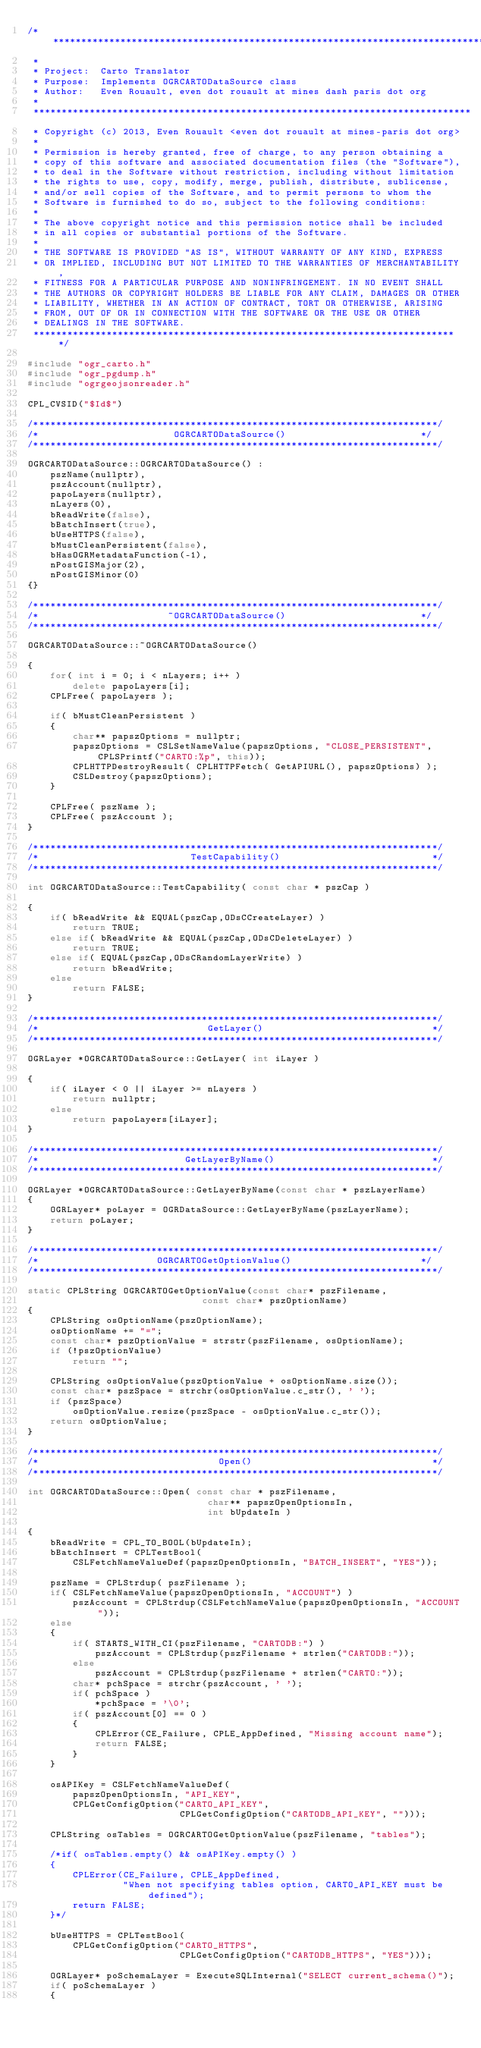<code> <loc_0><loc_0><loc_500><loc_500><_C++_>/******************************************************************************
 *
 * Project:  Carto Translator
 * Purpose:  Implements OGRCARTODataSource class
 * Author:   Even Rouault, even dot rouault at mines dash paris dot org
 *
 ******************************************************************************
 * Copyright (c) 2013, Even Rouault <even dot rouault at mines-paris dot org>
 *
 * Permission is hereby granted, free of charge, to any person obtaining a
 * copy of this software and associated documentation files (the "Software"),
 * to deal in the Software without restriction, including without limitation
 * the rights to use, copy, modify, merge, publish, distribute, sublicense,
 * and/or sell copies of the Software, and to permit persons to whom the
 * Software is furnished to do so, subject to the following conditions:
 *
 * The above copyright notice and this permission notice shall be included
 * in all copies or substantial portions of the Software.
 *
 * THE SOFTWARE IS PROVIDED "AS IS", WITHOUT WARRANTY OF ANY KIND, EXPRESS
 * OR IMPLIED, INCLUDING BUT NOT LIMITED TO THE WARRANTIES OF MERCHANTABILITY,
 * FITNESS FOR A PARTICULAR PURPOSE AND NONINFRINGEMENT. IN NO EVENT SHALL
 * THE AUTHORS OR COPYRIGHT HOLDERS BE LIABLE FOR ANY CLAIM, DAMAGES OR OTHER
 * LIABILITY, WHETHER IN AN ACTION OF CONTRACT, TORT OR OTHERWISE, ARISING
 * FROM, OUT OF OR IN CONNECTION WITH THE SOFTWARE OR THE USE OR OTHER
 * DEALINGS IN THE SOFTWARE.
 ****************************************************************************/

#include "ogr_carto.h"
#include "ogr_pgdump.h"
#include "ogrgeojsonreader.h"

CPL_CVSID("$Id$")

/************************************************************************/
/*                        OGRCARTODataSource()                        */
/************************************************************************/

OGRCARTODataSource::OGRCARTODataSource() :
    pszName(nullptr),
    pszAccount(nullptr),
    papoLayers(nullptr),
    nLayers(0),
    bReadWrite(false),
    bBatchInsert(true),
    bUseHTTPS(false),
    bMustCleanPersistent(false),
    bHasOGRMetadataFunction(-1),
    nPostGISMajor(2),
    nPostGISMinor(0)
{}

/************************************************************************/
/*                       ~OGRCARTODataSource()                        */
/************************************************************************/

OGRCARTODataSource::~OGRCARTODataSource()

{
    for( int i = 0; i < nLayers; i++ )
        delete papoLayers[i];
    CPLFree( papoLayers );

    if( bMustCleanPersistent )
    {
        char** papszOptions = nullptr;
        papszOptions = CSLSetNameValue(papszOptions, "CLOSE_PERSISTENT", CPLSPrintf("CARTO:%p", this));
        CPLHTTPDestroyResult( CPLHTTPFetch( GetAPIURL(), papszOptions) );
        CSLDestroy(papszOptions);
    }

    CPLFree( pszName );
    CPLFree( pszAccount );
}

/************************************************************************/
/*                           TestCapability()                           */
/************************************************************************/

int OGRCARTODataSource::TestCapability( const char * pszCap )

{
    if( bReadWrite && EQUAL(pszCap,ODsCCreateLayer) )
        return TRUE;
    else if( bReadWrite && EQUAL(pszCap,ODsCDeleteLayer) )
        return TRUE;
    else if( EQUAL(pszCap,ODsCRandomLayerWrite) )
        return bReadWrite;
    else
        return FALSE;
}

/************************************************************************/
/*                              GetLayer()                              */
/************************************************************************/

OGRLayer *OGRCARTODataSource::GetLayer( int iLayer )

{
    if( iLayer < 0 || iLayer >= nLayers )
        return nullptr;
    else
        return papoLayers[iLayer];
}

/************************************************************************/
/*                          GetLayerByName()                            */
/************************************************************************/

OGRLayer *OGRCARTODataSource::GetLayerByName(const char * pszLayerName)
{
    OGRLayer* poLayer = OGRDataSource::GetLayerByName(pszLayerName);
    return poLayer;
}

/************************************************************************/
/*                     OGRCARTOGetOptionValue()                       */
/************************************************************************/

static CPLString OGRCARTOGetOptionValue(const char* pszFilename,
                               const char* pszOptionName)
{
    CPLString osOptionName(pszOptionName);
    osOptionName += "=";
    const char* pszOptionValue = strstr(pszFilename, osOptionName);
    if (!pszOptionValue)
        return "";

    CPLString osOptionValue(pszOptionValue + osOptionName.size());
    const char* pszSpace = strchr(osOptionValue.c_str(), ' ');
    if (pszSpace)
        osOptionValue.resize(pszSpace - osOptionValue.c_str());
    return osOptionValue;
}

/************************************************************************/
/*                                Open()                                */
/************************************************************************/

int OGRCARTODataSource::Open( const char * pszFilename,
                                char** papszOpenOptionsIn,
                                int bUpdateIn )

{
    bReadWrite = CPL_TO_BOOL(bUpdateIn);
    bBatchInsert = CPLTestBool(
        CSLFetchNameValueDef(papszOpenOptionsIn, "BATCH_INSERT", "YES"));

    pszName = CPLStrdup( pszFilename );
    if( CSLFetchNameValue(papszOpenOptionsIn, "ACCOUNT") )
        pszAccount = CPLStrdup(CSLFetchNameValue(papszOpenOptionsIn, "ACCOUNT"));
    else
    {
        if( STARTS_WITH_CI(pszFilename, "CARTODB:") )
            pszAccount = CPLStrdup(pszFilename + strlen("CARTODB:"));
        else
            pszAccount = CPLStrdup(pszFilename + strlen("CARTO:"));
        char* pchSpace = strchr(pszAccount, ' ');
        if( pchSpace )
            *pchSpace = '\0';
        if( pszAccount[0] == 0 )
        {
            CPLError(CE_Failure, CPLE_AppDefined, "Missing account name");
            return FALSE;
        }
    }

    osAPIKey = CSLFetchNameValueDef(
        papszOpenOptionsIn, "API_KEY",
        CPLGetConfigOption("CARTO_API_KEY",
                           CPLGetConfigOption("CARTODB_API_KEY", "")));

    CPLString osTables = OGRCARTOGetOptionValue(pszFilename, "tables");

    /*if( osTables.empty() && osAPIKey.empty() )
    {
        CPLError(CE_Failure, CPLE_AppDefined,
                 "When not specifying tables option, CARTO_API_KEY must be defined");
        return FALSE;
    }*/

    bUseHTTPS = CPLTestBool(
        CPLGetConfigOption("CARTO_HTTPS",
                           CPLGetConfigOption("CARTODB_HTTPS", "YES")));

    OGRLayer* poSchemaLayer = ExecuteSQLInternal("SELECT current_schema()");
    if( poSchemaLayer )
    {</code> 